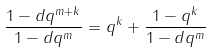Convert formula to latex. <formula><loc_0><loc_0><loc_500><loc_500>\frac { 1 - d q ^ { m + k } } { 1 - d q ^ { m } } = q ^ { k } + \frac { 1 - q ^ { k } } { 1 - d q ^ { m } }</formula> 